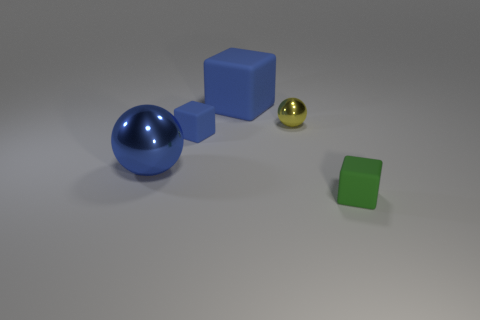How do the colors of the objects contribute to the overall aesthetic of the image? The colors create a contrast that is both harmonious and dynamic. The blue and green hues are cooler tones which complement each other, while the addition of the small yellow object provides a warm pop of color that draws the eye. The variation in color amongst these simple geometric shapes adds visual interest and highlights their individual forms. 